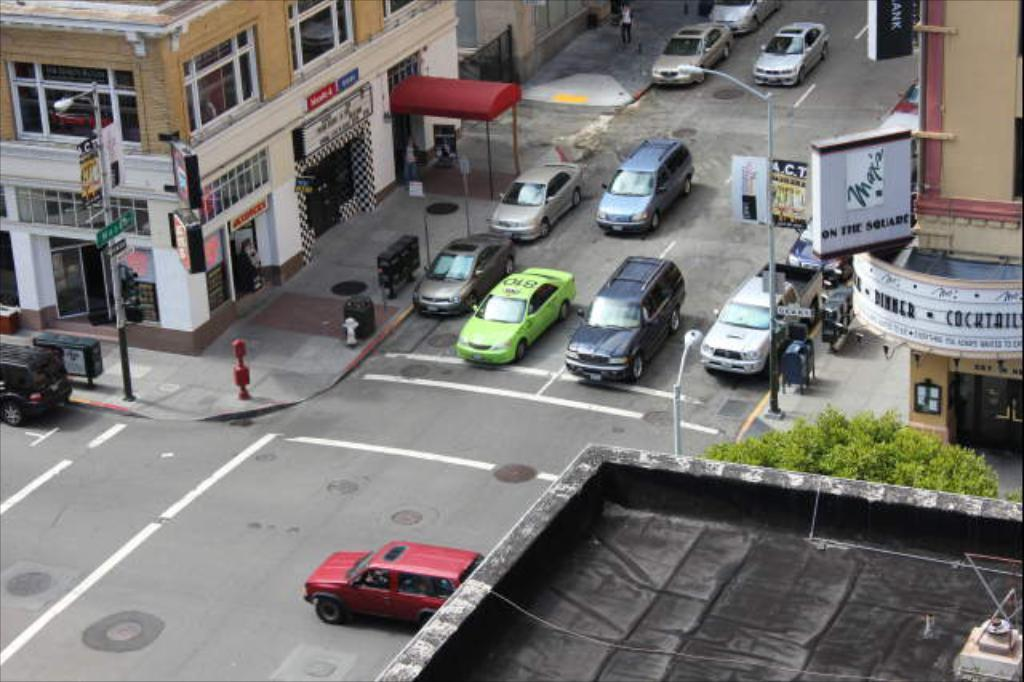What perspective is used in the image? The image is a top view. What can be seen moving on the road in the image? Vehicles are moving on the road in the image. What type of structures are present in the image? There are light poles, boards, trees, fire hydrants, and buildings visible in the image. What type of smoke can be seen coming from the wilderness in the image? There is no wilderness or smoke present in the image; it features a top view of a road with vehicles and various structures. 